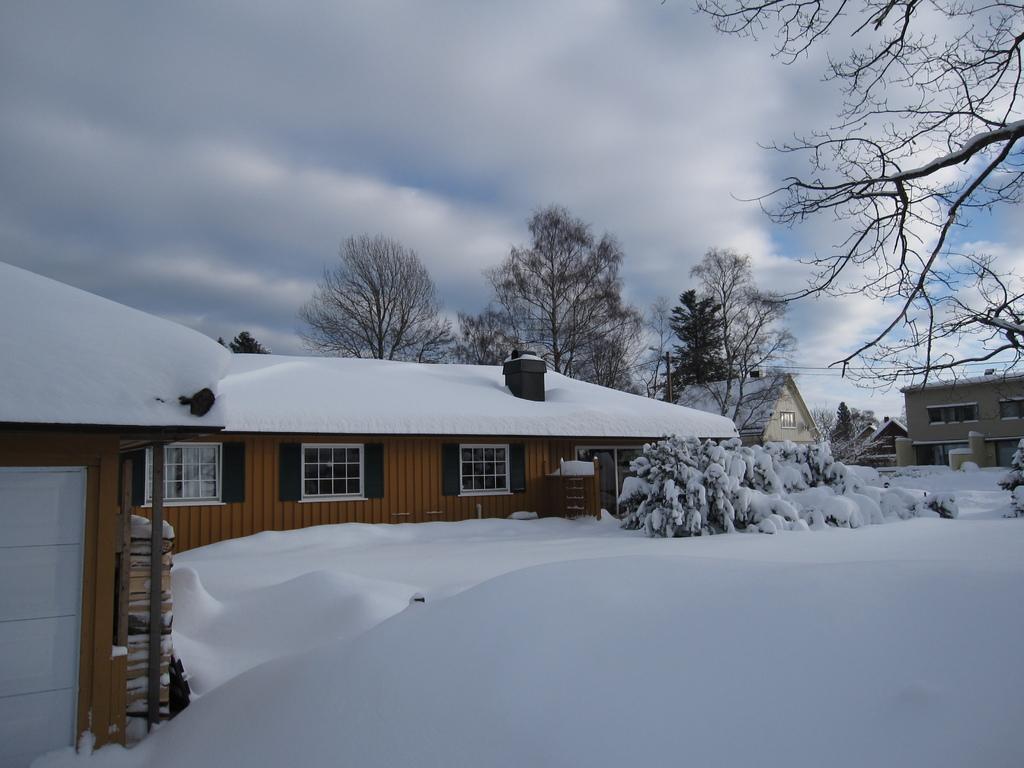In one or two sentences, can you explain what this image depicts? In this image in the center there are some houses, and on the houses there is snow. At the bottom there is snow and also there are some plants, on the plants there is snow. And in the background there are trees, at the top there is sky. 